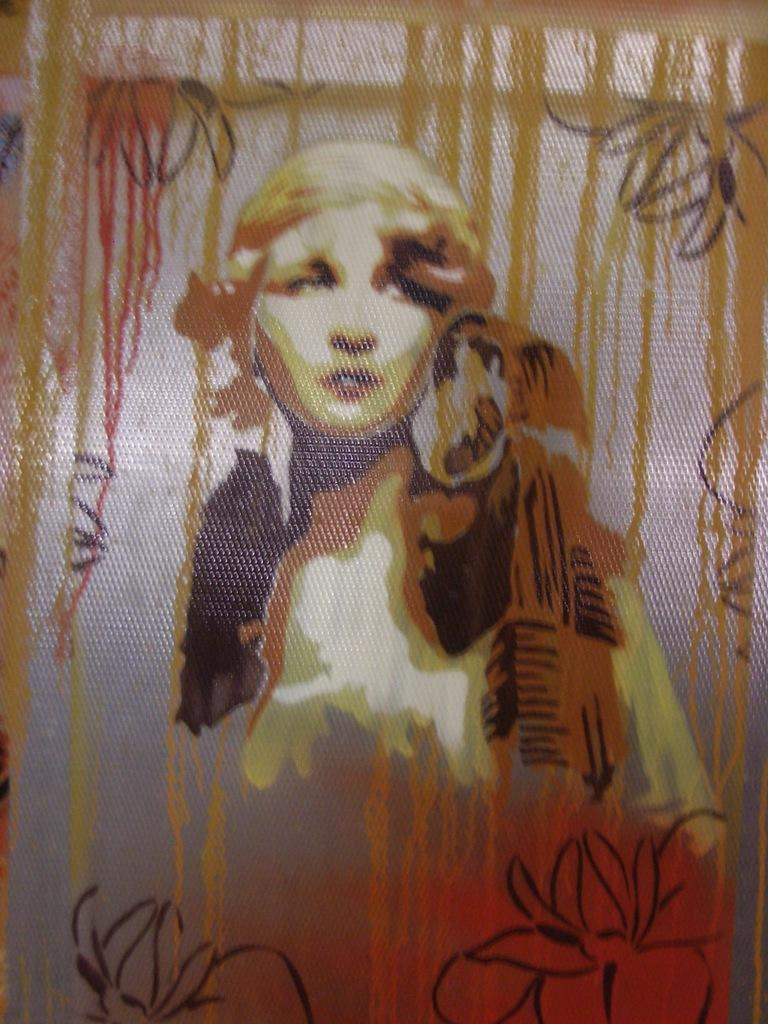What is depicted in the image? There is a painting in the image. What is the subject of the painting? The painting is of a person. On what type of surface is the painting displayed? The painting is on a glass surface. How many fangs can be seen in the painting? There are no fangs visible in the painting, as it is a portrait of a person. What type of hole is present in the painting? There is no hole present in the painting; it is a flat, two-dimensional image. 